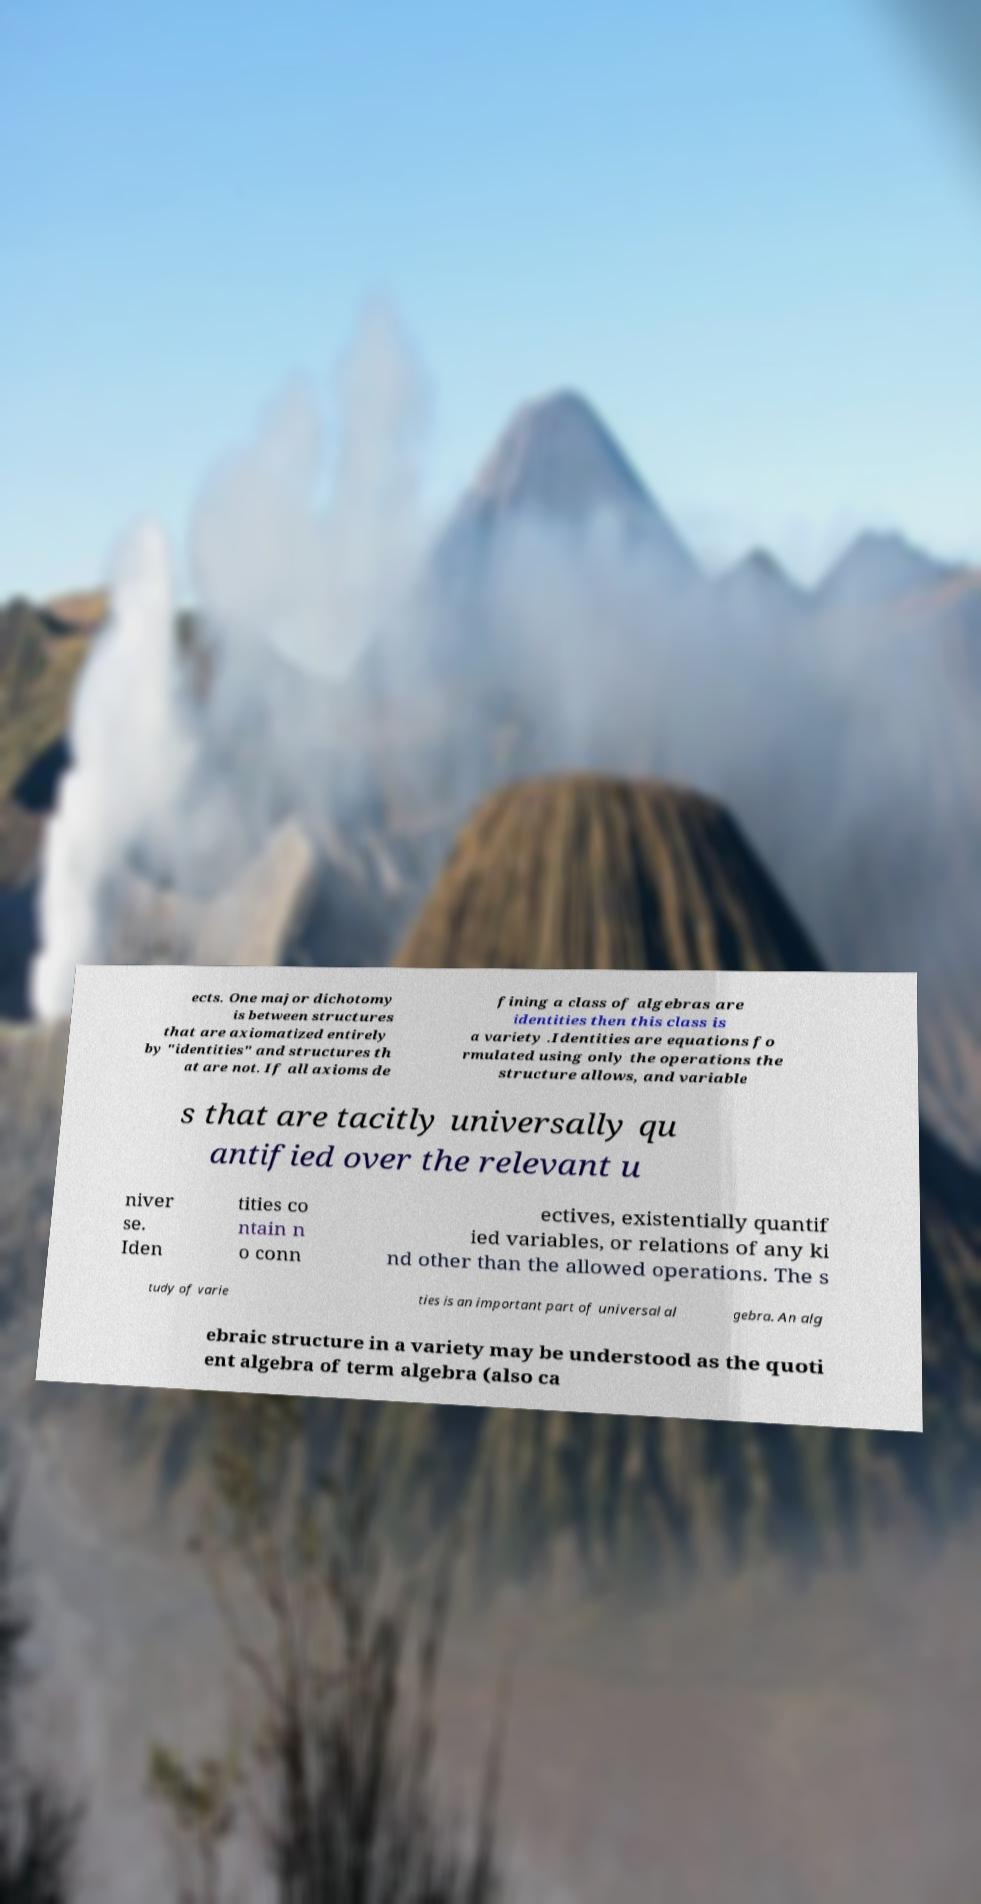I need the written content from this picture converted into text. Can you do that? ects. One major dichotomy is between structures that are axiomatized entirely by "identities" and structures th at are not. If all axioms de fining a class of algebras are identities then this class is a variety .Identities are equations fo rmulated using only the operations the structure allows, and variable s that are tacitly universally qu antified over the relevant u niver se. Iden tities co ntain n o conn ectives, existentially quantif ied variables, or relations of any ki nd other than the allowed operations. The s tudy of varie ties is an important part of universal al gebra. An alg ebraic structure in a variety may be understood as the quoti ent algebra of term algebra (also ca 